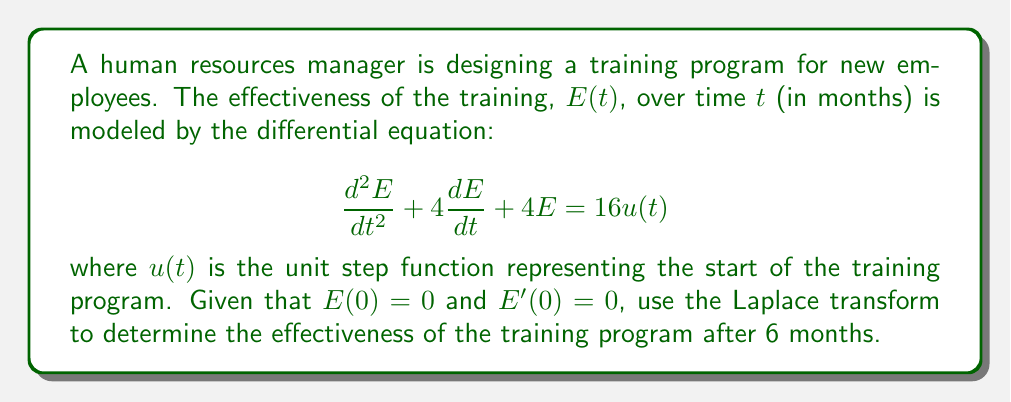Show me your answer to this math problem. To solve this problem, we'll use the Laplace transform method:

1) First, let's take the Laplace transform of both sides of the differential equation:

   $\mathcal{L}\{\frac{d^2E}{dt^2} + 4\frac{dE}{dt} + 4E\} = \mathcal{L}\{16u(t)\}$

2) Using the properties of Laplace transforms:

   $s^2E(s) - sE(0) - E'(0) + 4[sE(s) - E(0)] + 4E(s) = \frac{16}{s}$

3) Substitute the initial conditions $E(0) = 0$ and $E'(0) = 0$:

   $s^2E(s) + 4sE(s) + 4E(s) = \frac{16}{s}$

4) Factor out $E(s)$:

   $E(s)(s^2 + 4s + 4) = \frac{16}{s}$

5) Solve for $E(s)$:

   $E(s) = \frac{16}{s(s^2 + 4s + 4)} = \frac{16}{s(s+2)^2}$

6) Use partial fraction decomposition:

   $E(s) = \frac{A}{s} + \frac{B}{(s+2)} + \frac{C}{(s+2)^2}$

   Solving for A, B, and C:

   $A = 4$, $B = -8$, $C = 4$

7) Now we have:

   $E(s) = \frac{4}{s} - \frac{8}{s+2} + \frac{4}{(s+2)^2}$

8) Take the inverse Laplace transform:

   $E(t) = 4 - 8e^{-2t} + 4te^{-2t}$

9) To find the effectiveness after 6 months, substitute $t = 6$:

   $E(6) = 4 - 8e^{-12} + 24e^{-12}$

10) Simplify:

    $E(6) = 4 - 8(0.000006144) + 24(0.000006144) = 4 + 0.0001106 \approx 4.0001$
Answer: The effectiveness of the training program after 6 months is approximately 4.0001. 